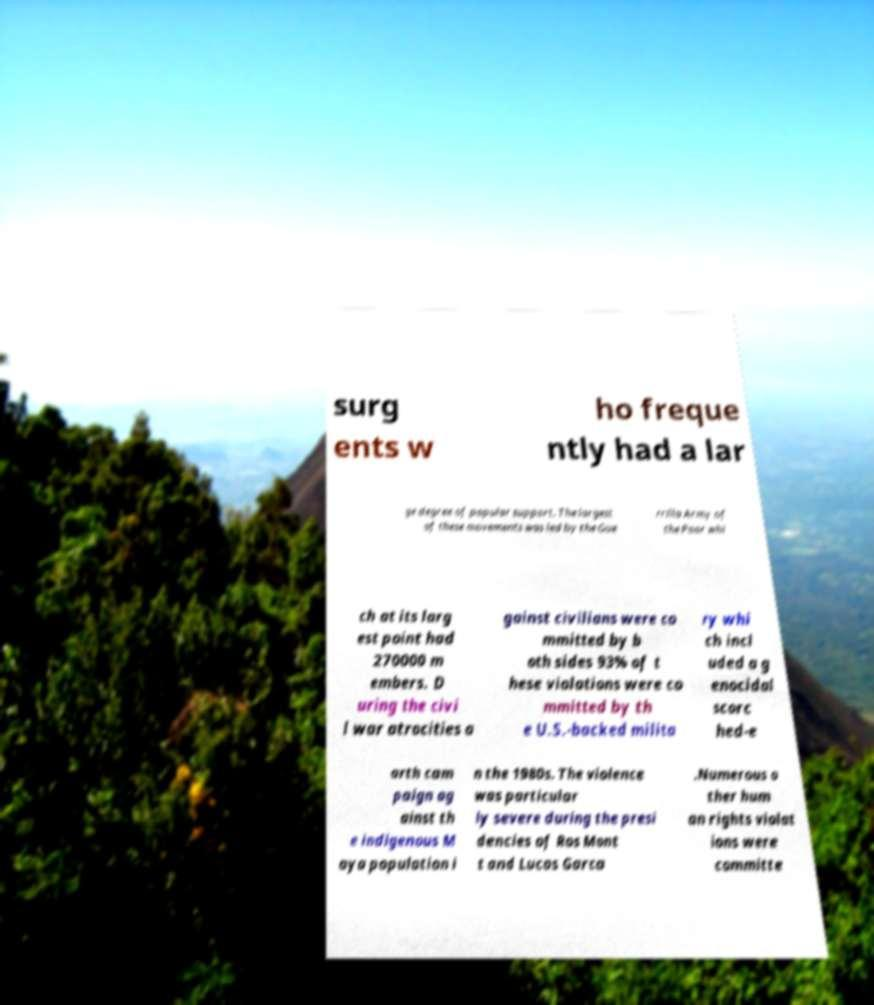Please identify and transcribe the text found in this image. surg ents w ho freque ntly had a lar ge degree of popular support. The largest of these movements was led by the Gue rrilla Army of the Poor whi ch at its larg est point had 270000 m embers. D uring the civi l war atrocities a gainst civilians were co mmitted by b oth sides 93% of t hese violations were co mmitted by th e U.S.-backed milita ry whi ch incl uded a g enocidal scorc hed-e arth cam paign ag ainst th e indigenous M aya population i n the 1980s. The violence was particular ly severe during the presi dencies of Ros Mont t and Lucas Garca .Numerous o ther hum an rights violat ions were committe 